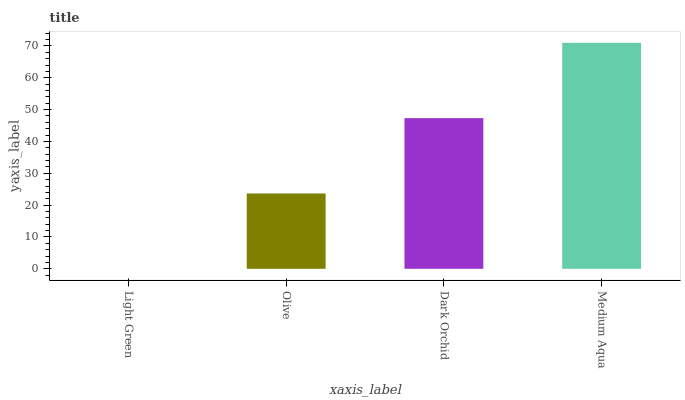Is Light Green the minimum?
Answer yes or no. Yes. Is Medium Aqua the maximum?
Answer yes or no. Yes. Is Olive the minimum?
Answer yes or no. No. Is Olive the maximum?
Answer yes or no. No. Is Olive greater than Light Green?
Answer yes or no. Yes. Is Light Green less than Olive?
Answer yes or no. Yes. Is Light Green greater than Olive?
Answer yes or no. No. Is Olive less than Light Green?
Answer yes or no. No. Is Dark Orchid the high median?
Answer yes or no. Yes. Is Olive the low median?
Answer yes or no. Yes. Is Olive the high median?
Answer yes or no. No. Is Light Green the low median?
Answer yes or no. No. 